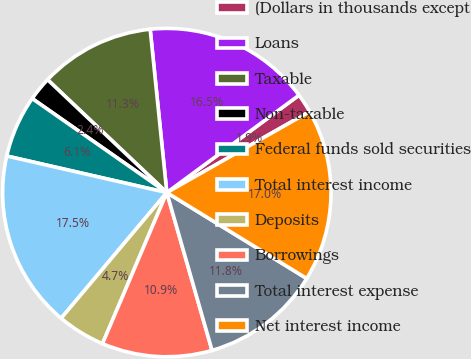<chart> <loc_0><loc_0><loc_500><loc_500><pie_chart><fcel>(Dollars in thousands except<fcel>Loans<fcel>Taxable<fcel>Non-taxable<fcel>Federal funds sold securities<fcel>Total interest income<fcel>Deposits<fcel>Borrowings<fcel>Total interest expense<fcel>Net interest income<nl><fcel>1.89%<fcel>16.51%<fcel>11.32%<fcel>2.36%<fcel>6.13%<fcel>17.45%<fcel>4.72%<fcel>10.85%<fcel>11.79%<fcel>16.98%<nl></chart> 